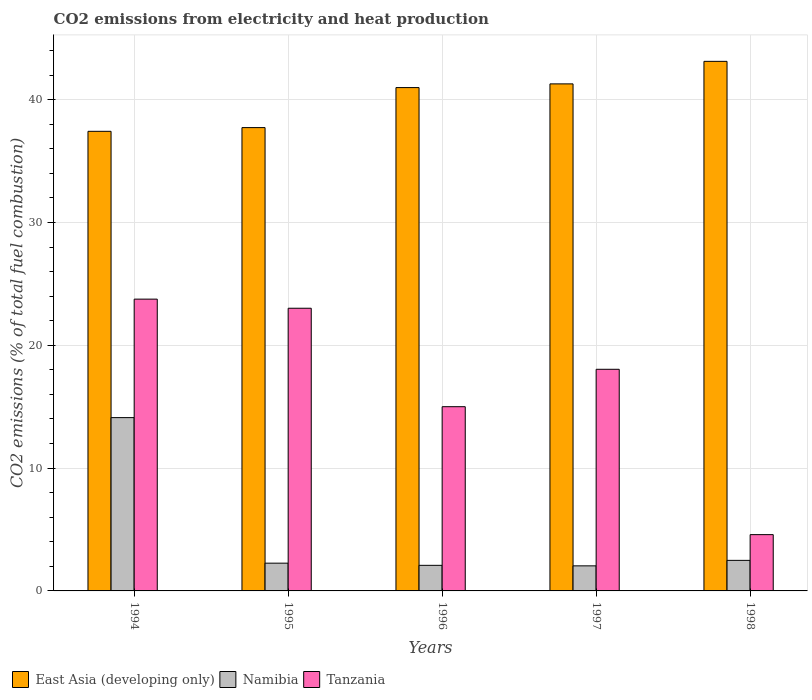How many groups of bars are there?
Ensure brevity in your answer.  5. Are the number of bars on each tick of the X-axis equal?
Make the answer very short. Yes. What is the label of the 3rd group of bars from the left?
Keep it short and to the point. 1996. What is the amount of CO2 emitted in Namibia in 1994?
Make the answer very short. 14.11. Across all years, what is the maximum amount of CO2 emitted in Namibia?
Provide a short and direct response. 14.11. Across all years, what is the minimum amount of CO2 emitted in Tanzania?
Give a very brief answer. 4.58. In which year was the amount of CO2 emitted in Tanzania minimum?
Ensure brevity in your answer.  1998. What is the total amount of CO2 emitted in East Asia (developing only) in the graph?
Offer a terse response. 200.52. What is the difference between the amount of CO2 emitted in Tanzania in 1997 and that in 1998?
Keep it short and to the point. 13.46. What is the difference between the amount of CO2 emitted in East Asia (developing only) in 1994 and the amount of CO2 emitted in Namibia in 1995?
Give a very brief answer. 35.16. What is the average amount of CO2 emitted in Namibia per year?
Give a very brief answer. 4.6. In the year 1996, what is the difference between the amount of CO2 emitted in Tanzania and amount of CO2 emitted in Namibia?
Your response must be concise. 12.92. In how many years, is the amount of CO2 emitted in Namibia greater than 16 %?
Provide a succinct answer. 0. What is the ratio of the amount of CO2 emitted in Namibia in 1994 to that in 1996?
Offer a very short reply. 6.77. Is the amount of CO2 emitted in Tanzania in 1994 less than that in 1995?
Offer a very short reply. No. What is the difference between the highest and the second highest amount of CO2 emitted in Namibia?
Ensure brevity in your answer.  11.62. What is the difference between the highest and the lowest amount of CO2 emitted in East Asia (developing only)?
Your answer should be very brief. 5.7. Is the sum of the amount of CO2 emitted in Namibia in 1995 and 1997 greater than the maximum amount of CO2 emitted in Tanzania across all years?
Ensure brevity in your answer.  No. What does the 1st bar from the left in 1996 represents?
Make the answer very short. East Asia (developing only). What does the 1st bar from the right in 1994 represents?
Your answer should be very brief. Tanzania. Is it the case that in every year, the sum of the amount of CO2 emitted in East Asia (developing only) and amount of CO2 emitted in Tanzania is greater than the amount of CO2 emitted in Namibia?
Your response must be concise. Yes. How many years are there in the graph?
Offer a terse response. 5. Are the values on the major ticks of Y-axis written in scientific E-notation?
Offer a terse response. No. Does the graph contain any zero values?
Keep it short and to the point. No. Does the graph contain grids?
Ensure brevity in your answer.  Yes. What is the title of the graph?
Offer a terse response. CO2 emissions from electricity and heat production. Does "Pakistan" appear as one of the legend labels in the graph?
Your response must be concise. No. What is the label or title of the X-axis?
Give a very brief answer. Years. What is the label or title of the Y-axis?
Your answer should be very brief. CO2 emissions (% of total fuel combustion). What is the CO2 emissions (% of total fuel combustion) in East Asia (developing only) in 1994?
Ensure brevity in your answer.  37.42. What is the CO2 emissions (% of total fuel combustion) in Namibia in 1994?
Your answer should be very brief. 14.11. What is the CO2 emissions (% of total fuel combustion) of Tanzania in 1994?
Your answer should be compact. 23.76. What is the CO2 emissions (% of total fuel combustion) in East Asia (developing only) in 1995?
Keep it short and to the point. 37.72. What is the CO2 emissions (% of total fuel combustion) of Namibia in 1995?
Offer a very short reply. 2.26. What is the CO2 emissions (% of total fuel combustion) of Tanzania in 1995?
Ensure brevity in your answer.  23.02. What is the CO2 emissions (% of total fuel combustion) in East Asia (developing only) in 1996?
Give a very brief answer. 40.98. What is the CO2 emissions (% of total fuel combustion) in Namibia in 1996?
Your response must be concise. 2.08. What is the CO2 emissions (% of total fuel combustion) of East Asia (developing only) in 1997?
Give a very brief answer. 41.28. What is the CO2 emissions (% of total fuel combustion) of Namibia in 1997?
Offer a very short reply. 2.04. What is the CO2 emissions (% of total fuel combustion) in Tanzania in 1997?
Your answer should be very brief. 18.05. What is the CO2 emissions (% of total fuel combustion) in East Asia (developing only) in 1998?
Your response must be concise. 43.12. What is the CO2 emissions (% of total fuel combustion) in Namibia in 1998?
Your answer should be compact. 2.49. What is the CO2 emissions (% of total fuel combustion) of Tanzania in 1998?
Make the answer very short. 4.58. Across all years, what is the maximum CO2 emissions (% of total fuel combustion) of East Asia (developing only)?
Your response must be concise. 43.12. Across all years, what is the maximum CO2 emissions (% of total fuel combustion) of Namibia?
Offer a terse response. 14.11. Across all years, what is the maximum CO2 emissions (% of total fuel combustion) of Tanzania?
Your response must be concise. 23.76. Across all years, what is the minimum CO2 emissions (% of total fuel combustion) of East Asia (developing only)?
Offer a very short reply. 37.42. Across all years, what is the minimum CO2 emissions (% of total fuel combustion) in Namibia?
Give a very brief answer. 2.04. Across all years, what is the minimum CO2 emissions (% of total fuel combustion) in Tanzania?
Give a very brief answer. 4.58. What is the total CO2 emissions (% of total fuel combustion) of East Asia (developing only) in the graph?
Offer a very short reply. 200.52. What is the total CO2 emissions (% of total fuel combustion) of Namibia in the graph?
Your response must be concise. 22.98. What is the total CO2 emissions (% of total fuel combustion) of Tanzania in the graph?
Ensure brevity in your answer.  84.4. What is the difference between the CO2 emissions (% of total fuel combustion) of East Asia (developing only) in 1994 and that in 1995?
Your response must be concise. -0.3. What is the difference between the CO2 emissions (% of total fuel combustion) in Namibia in 1994 and that in 1995?
Provide a short and direct response. 11.85. What is the difference between the CO2 emissions (% of total fuel combustion) of Tanzania in 1994 and that in 1995?
Offer a terse response. 0.74. What is the difference between the CO2 emissions (% of total fuel combustion) in East Asia (developing only) in 1994 and that in 1996?
Offer a very short reply. -3.56. What is the difference between the CO2 emissions (% of total fuel combustion) of Namibia in 1994 and that in 1996?
Your answer should be compact. 12.03. What is the difference between the CO2 emissions (% of total fuel combustion) in Tanzania in 1994 and that in 1996?
Give a very brief answer. 8.76. What is the difference between the CO2 emissions (% of total fuel combustion) of East Asia (developing only) in 1994 and that in 1997?
Ensure brevity in your answer.  -3.86. What is the difference between the CO2 emissions (% of total fuel combustion) of Namibia in 1994 and that in 1997?
Give a very brief answer. 12.07. What is the difference between the CO2 emissions (% of total fuel combustion) in Tanzania in 1994 and that in 1997?
Provide a succinct answer. 5.71. What is the difference between the CO2 emissions (% of total fuel combustion) of East Asia (developing only) in 1994 and that in 1998?
Make the answer very short. -5.7. What is the difference between the CO2 emissions (% of total fuel combustion) in Namibia in 1994 and that in 1998?
Keep it short and to the point. 11.62. What is the difference between the CO2 emissions (% of total fuel combustion) of Tanzania in 1994 and that in 1998?
Keep it short and to the point. 19.17. What is the difference between the CO2 emissions (% of total fuel combustion) of East Asia (developing only) in 1995 and that in 1996?
Your answer should be compact. -3.26. What is the difference between the CO2 emissions (% of total fuel combustion) in Namibia in 1995 and that in 1996?
Ensure brevity in your answer.  0.18. What is the difference between the CO2 emissions (% of total fuel combustion) of Tanzania in 1995 and that in 1996?
Offer a very short reply. 8.02. What is the difference between the CO2 emissions (% of total fuel combustion) in East Asia (developing only) in 1995 and that in 1997?
Your answer should be compact. -3.56. What is the difference between the CO2 emissions (% of total fuel combustion) of Namibia in 1995 and that in 1997?
Ensure brevity in your answer.  0.22. What is the difference between the CO2 emissions (% of total fuel combustion) in Tanzania in 1995 and that in 1997?
Provide a short and direct response. 4.97. What is the difference between the CO2 emissions (% of total fuel combustion) in East Asia (developing only) in 1995 and that in 1998?
Your answer should be very brief. -5.39. What is the difference between the CO2 emissions (% of total fuel combustion) in Namibia in 1995 and that in 1998?
Offer a very short reply. -0.23. What is the difference between the CO2 emissions (% of total fuel combustion) in Tanzania in 1995 and that in 1998?
Your response must be concise. 18.43. What is the difference between the CO2 emissions (% of total fuel combustion) in East Asia (developing only) in 1996 and that in 1997?
Provide a short and direct response. -0.3. What is the difference between the CO2 emissions (% of total fuel combustion) in Namibia in 1996 and that in 1997?
Give a very brief answer. 0.04. What is the difference between the CO2 emissions (% of total fuel combustion) of Tanzania in 1996 and that in 1997?
Give a very brief answer. -3.05. What is the difference between the CO2 emissions (% of total fuel combustion) of East Asia (developing only) in 1996 and that in 1998?
Ensure brevity in your answer.  -2.14. What is the difference between the CO2 emissions (% of total fuel combustion) in Namibia in 1996 and that in 1998?
Ensure brevity in your answer.  -0.4. What is the difference between the CO2 emissions (% of total fuel combustion) in Tanzania in 1996 and that in 1998?
Ensure brevity in your answer.  10.42. What is the difference between the CO2 emissions (% of total fuel combustion) in East Asia (developing only) in 1997 and that in 1998?
Offer a terse response. -1.83. What is the difference between the CO2 emissions (% of total fuel combustion) of Namibia in 1997 and that in 1998?
Your answer should be very brief. -0.45. What is the difference between the CO2 emissions (% of total fuel combustion) of Tanzania in 1997 and that in 1998?
Give a very brief answer. 13.46. What is the difference between the CO2 emissions (% of total fuel combustion) in East Asia (developing only) in 1994 and the CO2 emissions (% of total fuel combustion) in Namibia in 1995?
Your answer should be very brief. 35.16. What is the difference between the CO2 emissions (% of total fuel combustion) of East Asia (developing only) in 1994 and the CO2 emissions (% of total fuel combustion) of Tanzania in 1995?
Your answer should be very brief. 14.41. What is the difference between the CO2 emissions (% of total fuel combustion) of Namibia in 1994 and the CO2 emissions (% of total fuel combustion) of Tanzania in 1995?
Your answer should be very brief. -8.91. What is the difference between the CO2 emissions (% of total fuel combustion) in East Asia (developing only) in 1994 and the CO2 emissions (% of total fuel combustion) in Namibia in 1996?
Offer a terse response. 35.34. What is the difference between the CO2 emissions (% of total fuel combustion) of East Asia (developing only) in 1994 and the CO2 emissions (% of total fuel combustion) of Tanzania in 1996?
Offer a terse response. 22.42. What is the difference between the CO2 emissions (% of total fuel combustion) of Namibia in 1994 and the CO2 emissions (% of total fuel combustion) of Tanzania in 1996?
Your answer should be very brief. -0.89. What is the difference between the CO2 emissions (% of total fuel combustion) in East Asia (developing only) in 1994 and the CO2 emissions (% of total fuel combustion) in Namibia in 1997?
Give a very brief answer. 35.38. What is the difference between the CO2 emissions (% of total fuel combustion) in East Asia (developing only) in 1994 and the CO2 emissions (% of total fuel combustion) in Tanzania in 1997?
Your answer should be compact. 19.38. What is the difference between the CO2 emissions (% of total fuel combustion) of Namibia in 1994 and the CO2 emissions (% of total fuel combustion) of Tanzania in 1997?
Provide a short and direct response. -3.93. What is the difference between the CO2 emissions (% of total fuel combustion) in East Asia (developing only) in 1994 and the CO2 emissions (% of total fuel combustion) in Namibia in 1998?
Your response must be concise. 34.93. What is the difference between the CO2 emissions (% of total fuel combustion) of East Asia (developing only) in 1994 and the CO2 emissions (% of total fuel combustion) of Tanzania in 1998?
Your answer should be compact. 32.84. What is the difference between the CO2 emissions (% of total fuel combustion) of Namibia in 1994 and the CO2 emissions (% of total fuel combustion) of Tanzania in 1998?
Give a very brief answer. 9.53. What is the difference between the CO2 emissions (% of total fuel combustion) of East Asia (developing only) in 1995 and the CO2 emissions (% of total fuel combustion) of Namibia in 1996?
Your answer should be very brief. 35.64. What is the difference between the CO2 emissions (% of total fuel combustion) in East Asia (developing only) in 1995 and the CO2 emissions (% of total fuel combustion) in Tanzania in 1996?
Make the answer very short. 22.72. What is the difference between the CO2 emissions (% of total fuel combustion) of Namibia in 1995 and the CO2 emissions (% of total fuel combustion) of Tanzania in 1996?
Ensure brevity in your answer.  -12.74. What is the difference between the CO2 emissions (% of total fuel combustion) of East Asia (developing only) in 1995 and the CO2 emissions (% of total fuel combustion) of Namibia in 1997?
Your response must be concise. 35.68. What is the difference between the CO2 emissions (% of total fuel combustion) of East Asia (developing only) in 1995 and the CO2 emissions (% of total fuel combustion) of Tanzania in 1997?
Your response must be concise. 19.68. What is the difference between the CO2 emissions (% of total fuel combustion) of Namibia in 1995 and the CO2 emissions (% of total fuel combustion) of Tanzania in 1997?
Give a very brief answer. -15.79. What is the difference between the CO2 emissions (% of total fuel combustion) in East Asia (developing only) in 1995 and the CO2 emissions (% of total fuel combustion) in Namibia in 1998?
Your answer should be very brief. 35.24. What is the difference between the CO2 emissions (% of total fuel combustion) in East Asia (developing only) in 1995 and the CO2 emissions (% of total fuel combustion) in Tanzania in 1998?
Ensure brevity in your answer.  33.14. What is the difference between the CO2 emissions (% of total fuel combustion) of Namibia in 1995 and the CO2 emissions (% of total fuel combustion) of Tanzania in 1998?
Give a very brief answer. -2.32. What is the difference between the CO2 emissions (% of total fuel combustion) in East Asia (developing only) in 1996 and the CO2 emissions (% of total fuel combustion) in Namibia in 1997?
Your answer should be very brief. 38.94. What is the difference between the CO2 emissions (% of total fuel combustion) of East Asia (developing only) in 1996 and the CO2 emissions (% of total fuel combustion) of Tanzania in 1997?
Provide a succinct answer. 22.94. What is the difference between the CO2 emissions (% of total fuel combustion) in Namibia in 1996 and the CO2 emissions (% of total fuel combustion) in Tanzania in 1997?
Your answer should be compact. -15.96. What is the difference between the CO2 emissions (% of total fuel combustion) in East Asia (developing only) in 1996 and the CO2 emissions (% of total fuel combustion) in Namibia in 1998?
Your response must be concise. 38.49. What is the difference between the CO2 emissions (% of total fuel combustion) of East Asia (developing only) in 1996 and the CO2 emissions (% of total fuel combustion) of Tanzania in 1998?
Offer a very short reply. 36.4. What is the difference between the CO2 emissions (% of total fuel combustion) in Namibia in 1996 and the CO2 emissions (% of total fuel combustion) in Tanzania in 1998?
Offer a very short reply. -2.5. What is the difference between the CO2 emissions (% of total fuel combustion) of East Asia (developing only) in 1997 and the CO2 emissions (% of total fuel combustion) of Namibia in 1998?
Make the answer very short. 38.8. What is the difference between the CO2 emissions (% of total fuel combustion) in East Asia (developing only) in 1997 and the CO2 emissions (% of total fuel combustion) in Tanzania in 1998?
Provide a succinct answer. 36.7. What is the difference between the CO2 emissions (% of total fuel combustion) of Namibia in 1997 and the CO2 emissions (% of total fuel combustion) of Tanzania in 1998?
Make the answer very short. -2.54. What is the average CO2 emissions (% of total fuel combustion) of East Asia (developing only) per year?
Provide a succinct answer. 40.1. What is the average CO2 emissions (% of total fuel combustion) in Namibia per year?
Offer a terse response. 4.6. What is the average CO2 emissions (% of total fuel combustion) in Tanzania per year?
Provide a succinct answer. 16.88. In the year 1994, what is the difference between the CO2 emissions (% of total fuel combustion) in East Asia (developing only) and CO2 emissions (% of total fuel combustion) in Namibia?
Give a very brief answer. 23.31. In the year 1994, what is the difference between the CO2 emissions (% of total fuel combustion) of East Asia (developing only) and CO2 emissions (% of total fuel combustion) of Tanzania?
Offer a very short reply. 13.66. In the year 1994, what is the difference between the CO2 emissions (% of total fuel combustion) in Namibia and CO2 emissions (% of total fuel combustion) in Tanzania?
Ensure brevity in your answer.  -9.65. In the year 1995, what is the difference between the CO2 emissions (% of total fuel combustion) of East Asia (developing only) and CO2 emissions (% of total fuel combustion) of Namibia?
Provide a succinct answer. 35.46. In the year 1995, what is the difference between the CO2 emissions (% of total fuel combustion) of East Asia (developing only) and CO2 emissions (% of total fuel combustion) of Tanzania?
Your response must be concise. 14.71. In the year 1995, what is the difference between the CO2 emissions (% of total fuel combustion) of Namibia and CO2 emissions (% of total fuel combustion) of Tanzania?
Provide a succinct answer. -20.76. In the year 1996, what is the difference between the CO2 emissions (% of total fuel combustion) in East Asia (developing only) and CO2 emissions (% of total fuel combustion) in Namibia?
Offer a very short reply. 38.9. In the year 1996, what is the difference between the CO2 emissions (% of total fuel combustion) of East Asia (developing only) and CO2 emissions (% of total fuel combustion) of Tanzania?
Provide a short and direct response. 25.98. In the year 1996, what is the difference between the CO2 emissions (% of total fuel combustion) of Namibia and CO2 emissions (% of total fuel combustion) of Tanzania?
Your answer should be compact. -12.92. In the year 1997, what is the difference between the CO2 emissions (% of total fuel combustion) of East Asia (developing only) and CO2 emissions (% of total fuel combustion) of Namibia?
Ensure brevity in your answer.  39.24. In the year 1997, what is the difference between the CO2 emissions (% of total fuel combustion) of East Asia (developing only) and CO2 emissions (% of total fuel combustion) of Tanzania?
Your answer should be very brief. 23.24. In the year 1997, what is the difference between the CO2 emissions (% of total fuel combustion) in Namibia and CO2 emissions (% of total fuel combustion) in Tanzania?
Your answer should be compact. -16. In the year 1998, what is the difference between the CO2 emissions (% of total fuel combustion) of East Asia (developing only) and CO2 emissions (% of total fuel combustion) of Namibia?
Offer a terse response. 40.63. In the year 1998, what is the difference between the CO2 emissions (% of total fuel combustion) of East Asia (developing only) and CO2 emissions (% of total fuel combustion) of Tanzania?
Your response must be concise. 38.53. In the year 1998, what is the difference between the CO2 emissions (% of total fuel combustion) of Namibia and CO2 emissions (% of total fuel combustion) of Tanzania?
Your response must be concise. -2.1. What is the ratio of the CO2 emissions (% of total fuel combustion) of Namibia in 1994 to that in 1995?
Keep it short and to the point. 6.24. What is the ratio of the CO2 emissions (% of total fuel combustion) in Tanzania in 1994 to that in 1995?
Provide a succinct answer. 1.03. What is the ratio of the CO2 emissions (% of total fuel combustion) of East Asia (developing only) in 1994 to that in 1996?
Your answer should be very brief. 0.91. What is the ratio of the CO2 emissions (% of total fuel combustion) in Namibia in 1994 to that in 1996?
Your answer should be very brief. 6.77. What is the ratio of the CO2 emissions (% of total fuel combustion) of Tanzania in 1994 to that in 1996?
Make the answer very short. 1.58. What is the ratio of the CO2 emissions (% of total fuel combustion) of East Asia (developing only) in 1994 to that in 1997?
Your response must be concise. 0.91. What is the ratio of the CO2 emissions (% of total fuel combustion) in Namibia in 1994 to that in 1997?
Your response must be concise. 6.91. What is the ratio of the CO2 emissions (% of total fuel combustion) in Tanzania in 1994 to that in 1997?
Offer a terse response. 1.32. What is the ratio of the CO2 emissions (% of total fuel combustion) of East Asia (developing only) in 1994 to that in 1998?
Provide a succinct answer. 0.87. What is the ratio of the CO2 emissions (% of total fuel combustion) of Namibia in 1994 to that in 1998?
Give a very brief answer. 5.67. What is the ratio of the CO2 emissions (% of total fuel combustion) of Tanzania in 1994 to that in 1998?
Offer a very short reply. 5.18. What is the ratio of the CO2 emissions (% of total fuel combustion) in East Asia (developing only) in 1995 to that in 1996?
Provide a short and direct response. 0.92. What is the ratio of the CO2 emissions (% of total fuel combustion) in Namibia in 1995 to that in 1996?
Your answer should be compact. 1.08. What is the ratio of the CO2 emissions (% of total fuel combustion) of Tanzania in 1995 to that in 1996?
Your response must be concise. 1.53. What is the ratio of the CO2 emissions (% of total fuel combustion) in East Asia (developing only) in 1995 to that in 1997?
Your answer should be compact. 0.91. What is the ratio of the CO2 emissions (% of total fuel combustion) in Namibia in 1995 to that in 1997?
Ensure brevity in your answer.  1.11. What is the ratio of the CO2 emissions (% of total fuel combustion) of Tanzania in 1995 to that in 1997?
Give a very brief answer. 1.28. What is the ratio of the CO2 emissions (% of total fuel combustion) in East Asia (developing only) in 1995 to that in 1998?
Your response must be concise. 0.87. What is the ratio of the CO2 emissions (% of total fuel combustion) in Namibia in 1995 to that in 1998?
Provide a succinct answer. 0.91. What is the ratio of the CO2 emissions (% of total fuel combustion) in Tanzania in 1995 to that in 1998?
Your answer should be compact. 5.02. What is the ratio of the CO2 emissions (% of total fuel combustion) of East Asia (developing only) in 1996 to that in 1997?
Provide a short and direct response. 0.99. What is the ratio of the CO2 emissions (% of total fuel combustion) in Namibia in 1996 to that in 1997?
Ensure brevity in your answer.  1.02. What is the ratio of the CO2 emissions (% of total fuel combustion) of Tanzania in 1996 to that in 1997?
Provide a succinct answer. 0.83. What is the ratio of the CO2 emissions (% of total fuel combustion) of East Asia (developing only) in 1996 to that in 1998?
Provide a succinct answer. 0.95. What is the ratio of the CO2 emissions (% of total fuel combustion) in Namibia in 1996 to that in 1998?
Offer a terse response. 0.84. What is the ratio of the CO2 emissions (% of total fuel combustion) of Tanzania in 1996 to that in 1998?
Give a very brief answer. 3.27. What is the ratio of the CO2 emissions (% of total fuel combustion) in East Asia (developing only) in 1997 to that in 1998?
Provide a short and direct response. 0.96. What is the ratio of the CO2 emissions (% of total fuel combustion) of Namibia in 1997 to that in 1998?
Your response must be concise. 0.82. What is the ratio of the CO2 emissions (% of total fuel combustion) in Tanzania in 1997 to that in 1998?
Offer a terse response. 3.94. What is the difference between the highest and the second highest CO2 emissions (% of total fuel combustion) of East Asia (developing only)?
Your answer should be very brief. 1.83. What is the difference between the highest and the second highest CO2 emissions (% of total fuel combustion) in Namibia?
Make the answer very short. 11.62. What is the difference between the highest and the second highest CO2 emissions (% of total fuel combustion) of Tanzania?
Ensure brevity in your answer.  0.74. What is the difference between the highest and the lowest CO2 emissions (% of total fuel combustion) in East Asia (developing only)?
Keep it short and to the point. 5.7. What is the difference between the highest and the lowest CO2 emissions (% of total fuel combustion) in Namibia?
Provide a succinct answer. 12.07. What is the difference between the highest and the lowest CO2 emissions (% of total fuel combustion) of Tanzania?
Offer a very short reply. 19.17. 